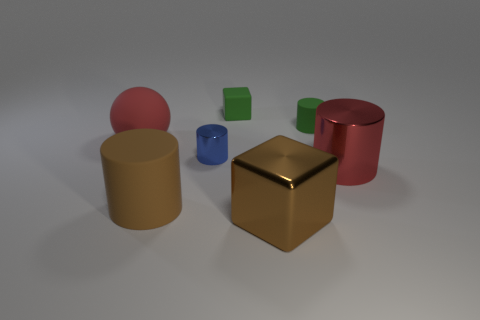Are there more tiny rubber cubes on the right side of the big metal cylinder than big brown things?
Make the answer very short. No. There is a big matte object that is to the right of the red matte ball; what color is it?
Make the answer very short. Brown. Is the size of the red metal thing the same as the blue thing?
Offer a terse response. No. The brown cylinder is what size?
Keep it short and to the point. Large. The thing that is the same color as the large rubber cylinder is what shape?
Your answer should be compact. Cube. Is the number of tiny blue objects greater than the number of brown metal cylinders?
Offer a very short reply. Yes. What color is the metallic thing that is to the left of the small rubber thing behind the tiny cylinder that is behind the big sphere?
Offer a terse response. Blue. There is a large red object to the right of the red matte sphere; is its shape the same as the blue metal thing?
Your answer should be very brief. Yes. The matte object that is the same size as the green matte block is what color?
Provide a short and direct response. Green. How many metal things are there?
Offer a terse response. 3. 